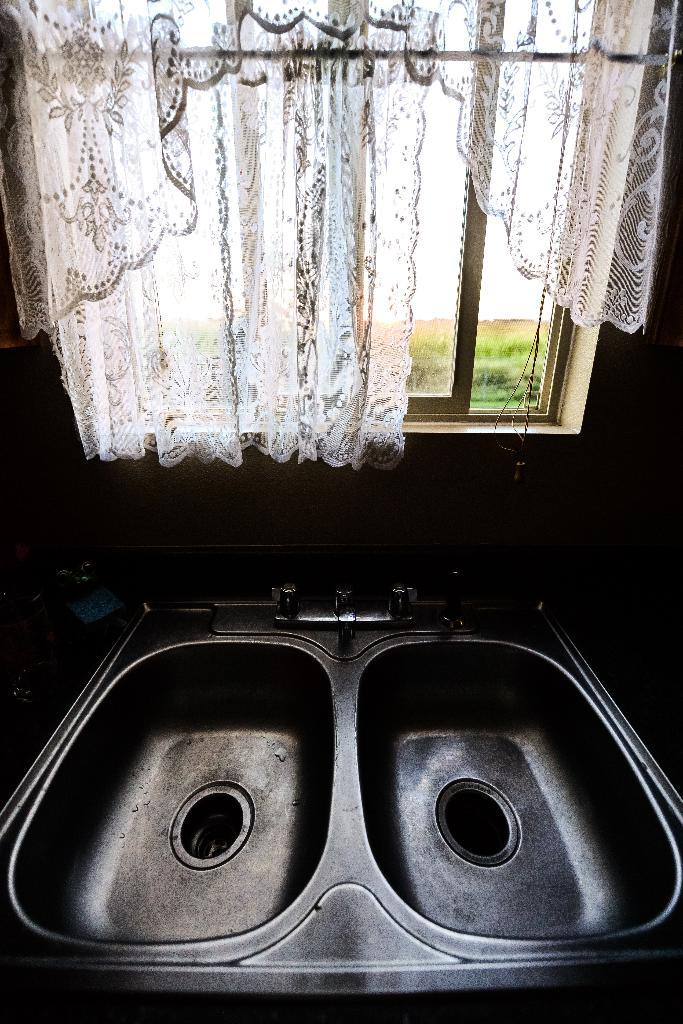What type of equipment can be seen at the bottom side of the image? There are sanitary equipment at the bottom side of the image. What is located in the center of the image? There is a window with a curtain in the center of the image. What can be seen outside the window? There is greenery outside the window. What type of blade is visible in the image? There is no blade present in the image. Is there a letter addressed to someone in the image? There is no letter visible in the image. 